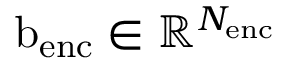<formula> <loc_0><loc_0><loc_500><loc_500>b _ { e n c } \in \mathbb { R } ^ { N _ { e n c } }</formula> 